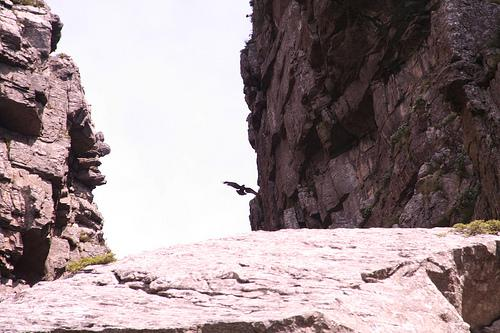Question: what color are the rocks?
Choices:
A. White.
B. Brown.
C. Pink.
D. Red.
Answer with the letter. Answer: C Question: what is happening in this picture?
Choices:
A. A bird is flying.
B. A bird is bathing.
C. A plane is in the air.
D. A bird is hopping.
Answer with the letter. Answer: A Question: what time of day is it?
Choices:
A. Dawn.
B. Dusk.
C. Midday.
D. Afternoon.
Answer with the letter. Answer: C Question: what is the bird doing?
Choices:
A. Splashing in water.
B. Preening itself.
C. Flying.
D. Pecking at food.
Answer with the letter. Answer: C 